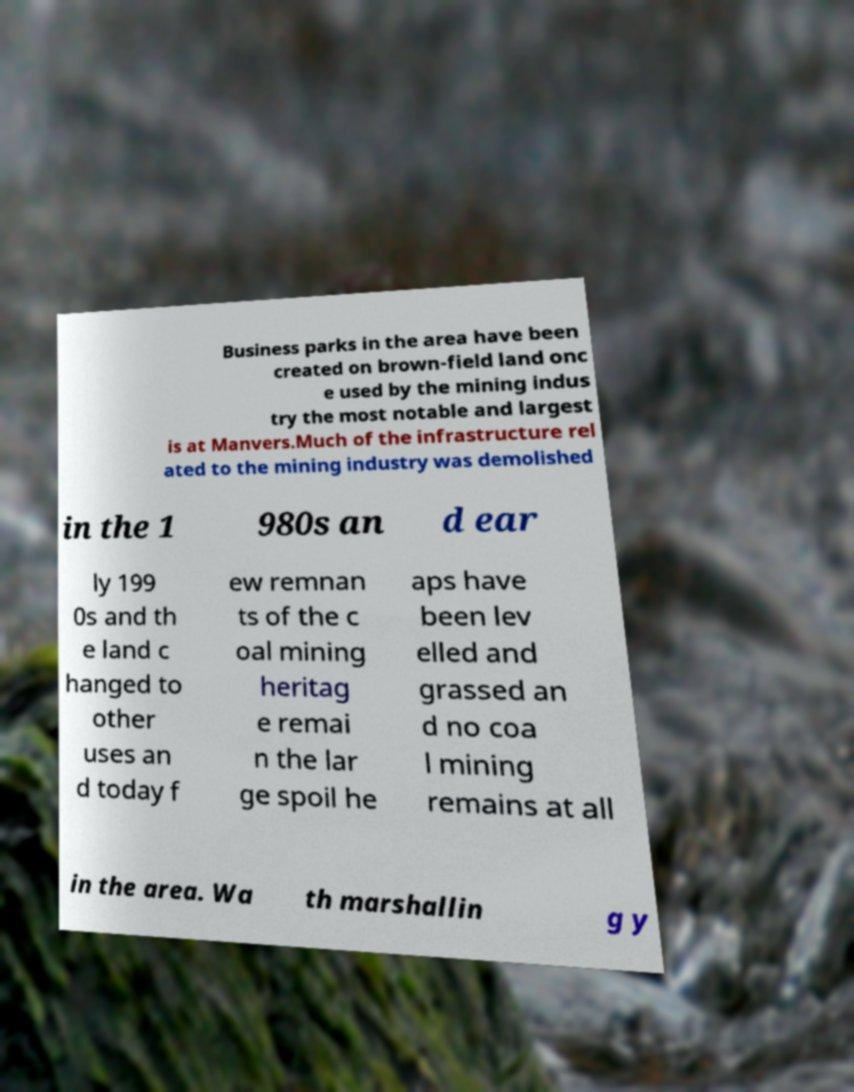Can you read and provide the text displayed in the image?This photo seems to have some interesting text. Can you extract and type it out for me? Business parks in the area have been created on brown-field land onc e used by the mining indus try the most notable and largest is at Manvers.Much of the infrastructure rel ated to the mining industry was demolished in the 1 980s an d ear ly 199 0s and th e land c hanged to other uses an d today f ew remnan ts of the c oal mining heritag e remai n the lar ge spoil he aps have been lev elled and grassed an d no coa l mining remains at all in the area. Wa th marshallin g y 